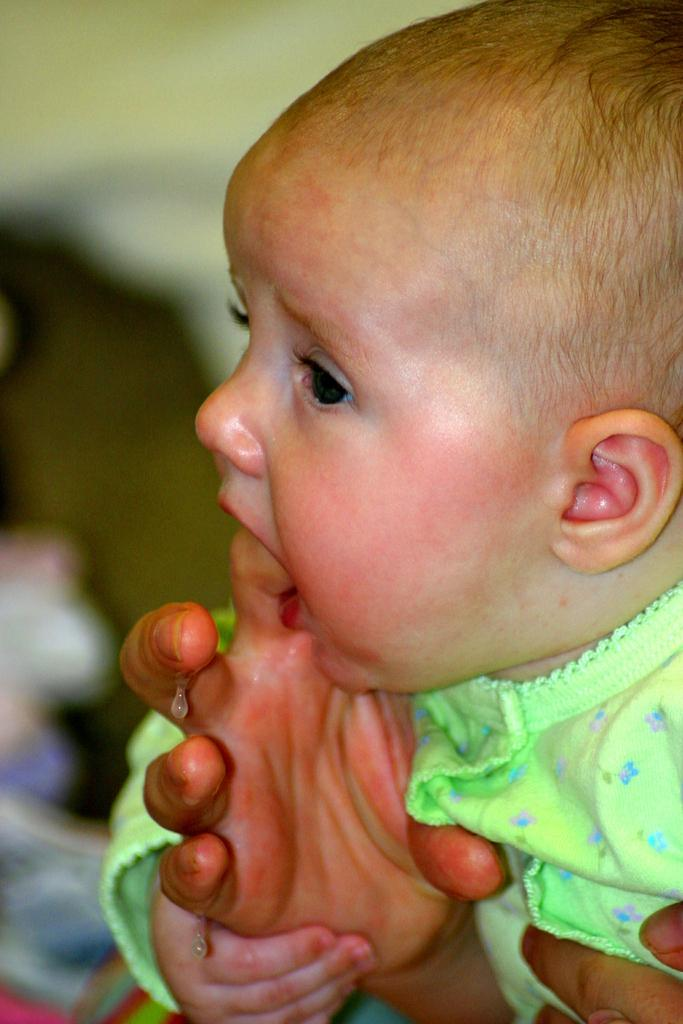What is the main subject of the image? There is a child in the image. Can you describe the child's clothing? The child is wearing a green dress. How would you describe the background of the image? The background of the image is blurred. Can you see any bees buzzing around the child in the image? There are no bees visible in the image. What type of rest is the child taking in the image? The image does not show the child resting; they are standing or sitting. 